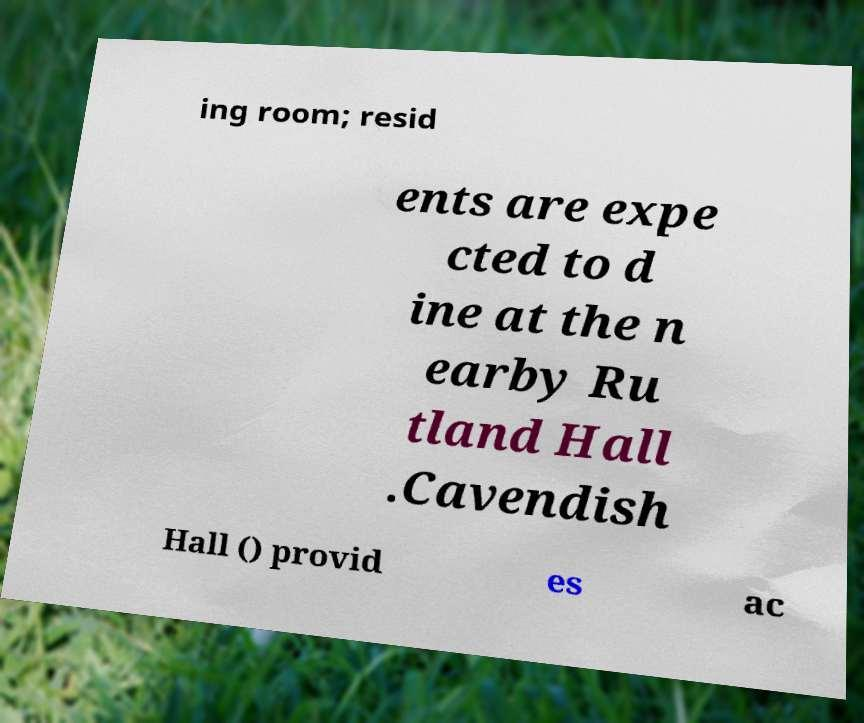What messages or text are displayed in this image? I need them in a readable, typed format. ing room; resid ents are expe cted to d ine at the n earby Ru tland Hall .Cavendish Hall () provid es ac 